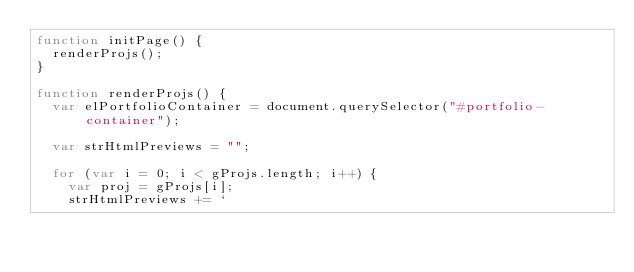<code> <loc_0><loc_0><loc_500><loc_500><_JavaScript_>function initPage() {
  renderProjs();
}

function renderProjs() {
  var elPortfolioContainer = document.querySelector("#portfolio-container");

  var strHtmlPreviews = "";

  for (var i = 0; i < gProjs.length; i++) {
    var proj = gProjs[i];
    strHtmlPreviews += `</code> 